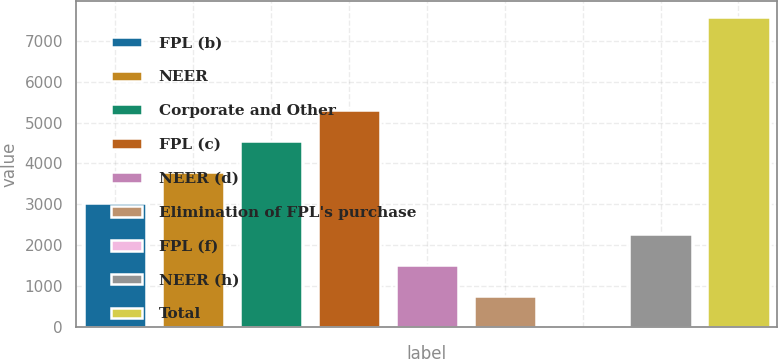Convert chart to OTSL. <chart><loc_0><loc_0><loc_500><loc_500><bar_chart><fcel>FPL (b)<fcel>NEER<fcel>Corporate and Other<fcel>FPL (c)<fcel>NEER (d)<fcel>Elimination of FPL's purchase<fcel>FPL (f)<fcel>NEER (h)<fcel>Total<nl><fcel>3038.8<fcel>3798<fcel>4557.2<fcel>5316.4<fcel>1520.4<fcel>761.2<fcel>2<fcel>2279.6<fcel>7594<nl></chart> 